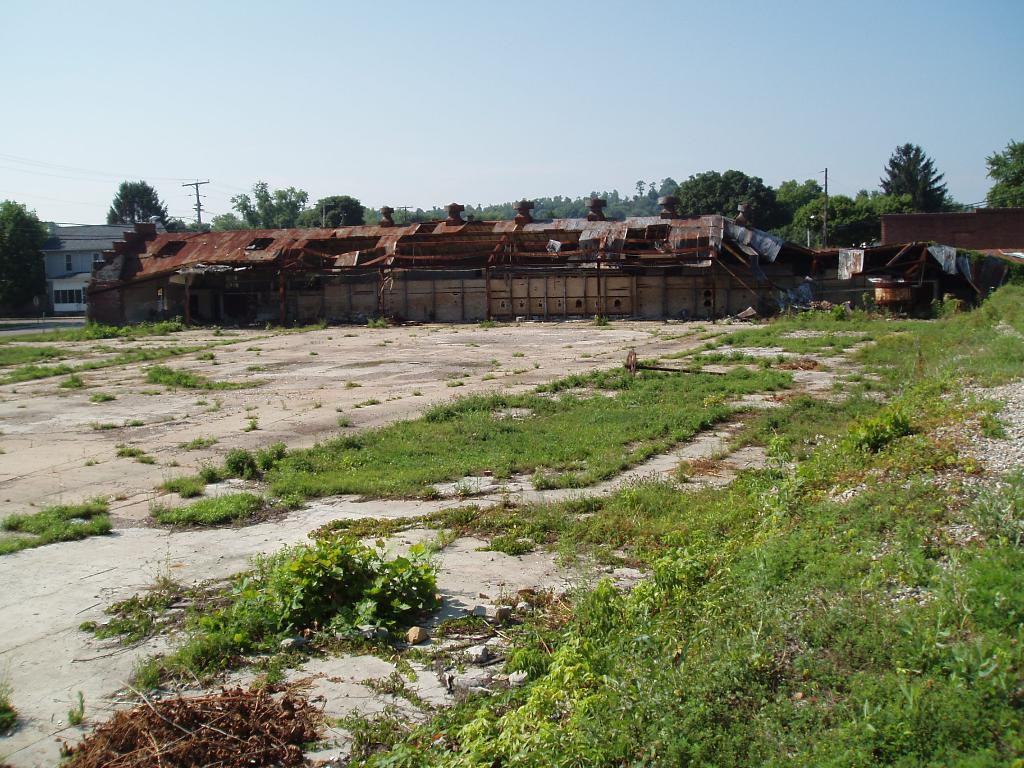What type of vegetation can be seen in the image? There is grass and plants in the image. What type of structures are visible in the image? There are houses in the image. What other objects can be seen in the image? There are poles and trees in the image. What is visible in the background of the image? The sky is visible in the image. Where is the sofa located in the image? There is no sofa present in the image. What type of force is being exerted on the trees in the image? There is no indication of any force being exerted on the trees in the image. 